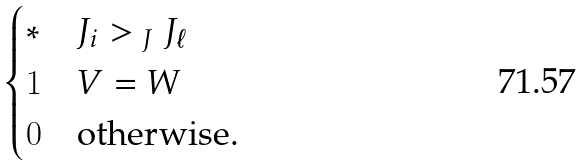<formula> <loc_0><loc_0><loc_500><loc_500>\begin{cases} \ast & J _ { i } > _ { \ J } J _ { \ell } \\ 1 & V = W \\ 0 & \text {otherwise.} \end{cases}</formula> 